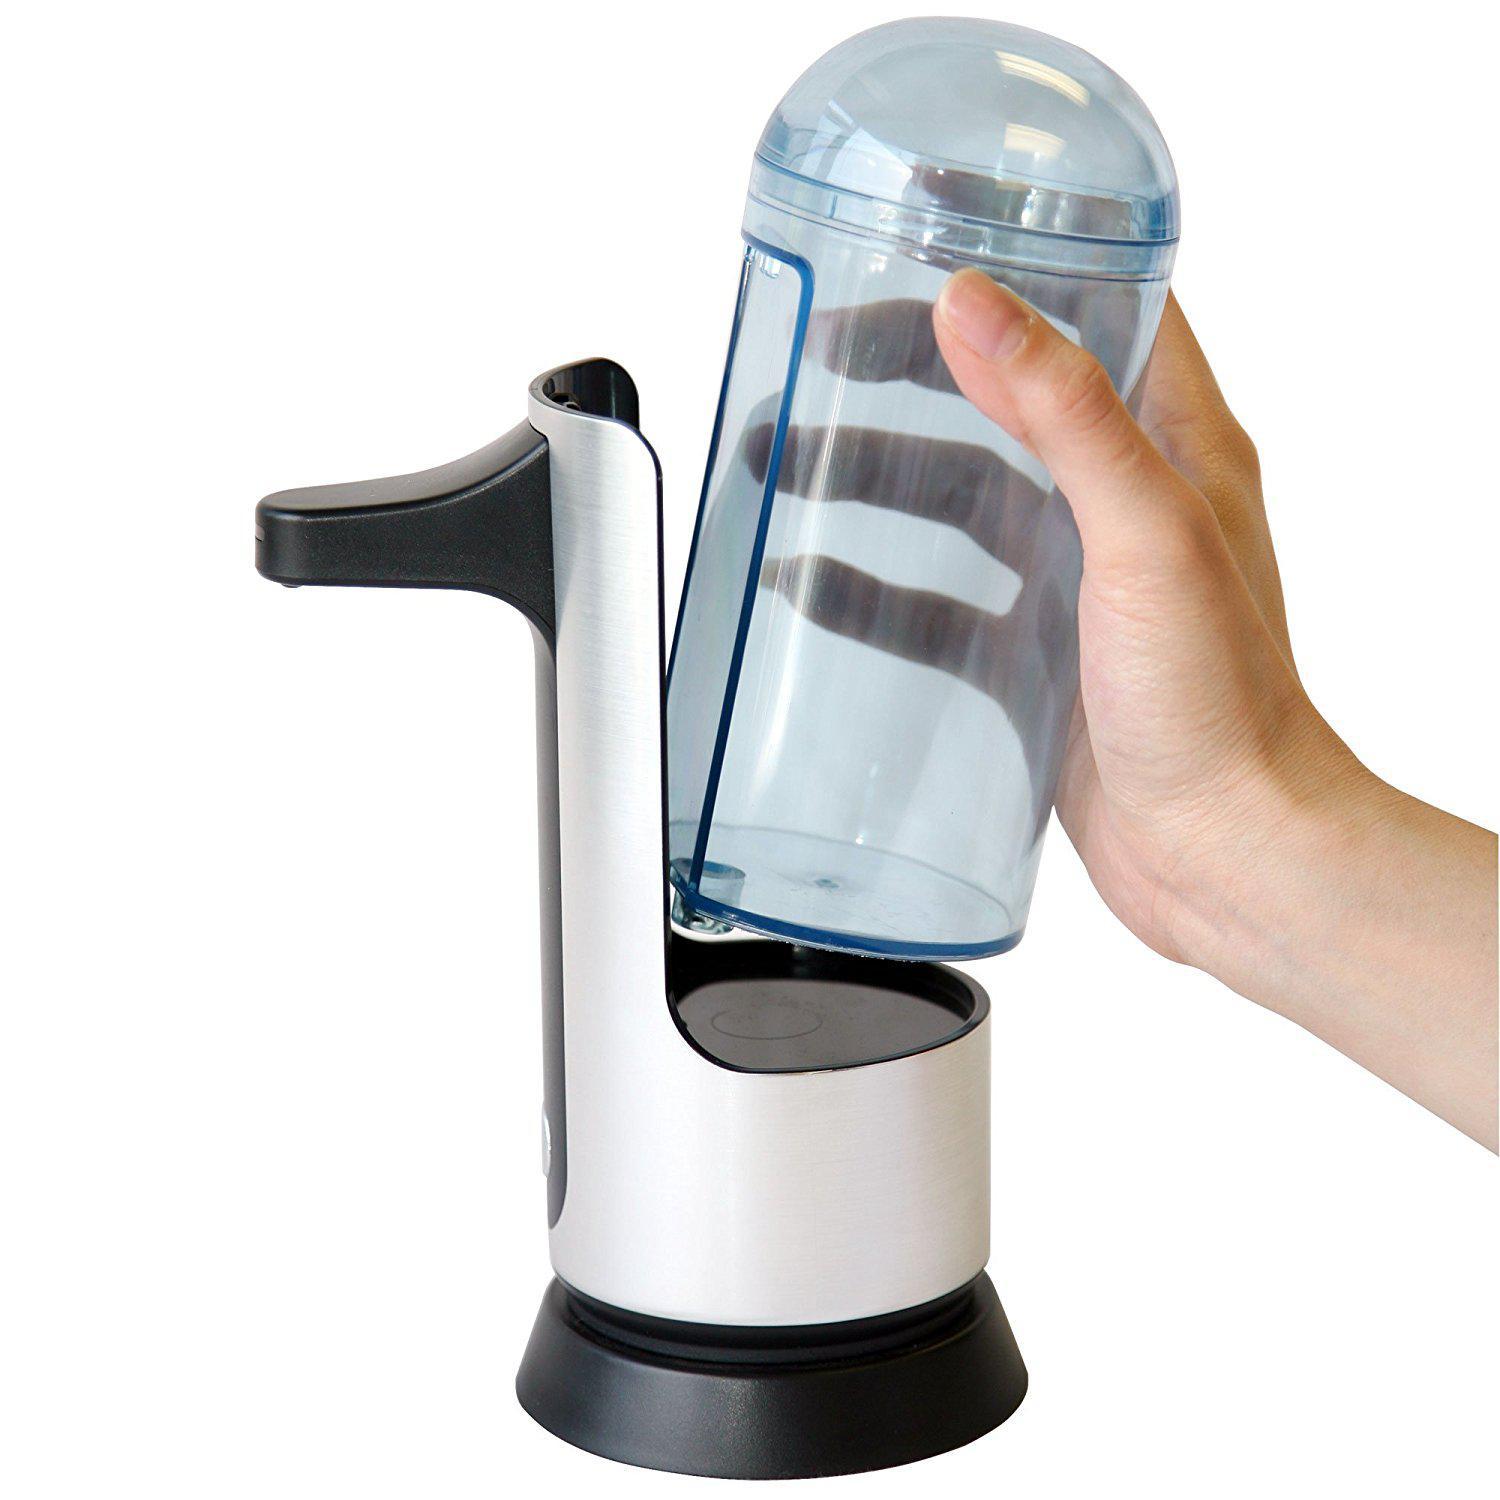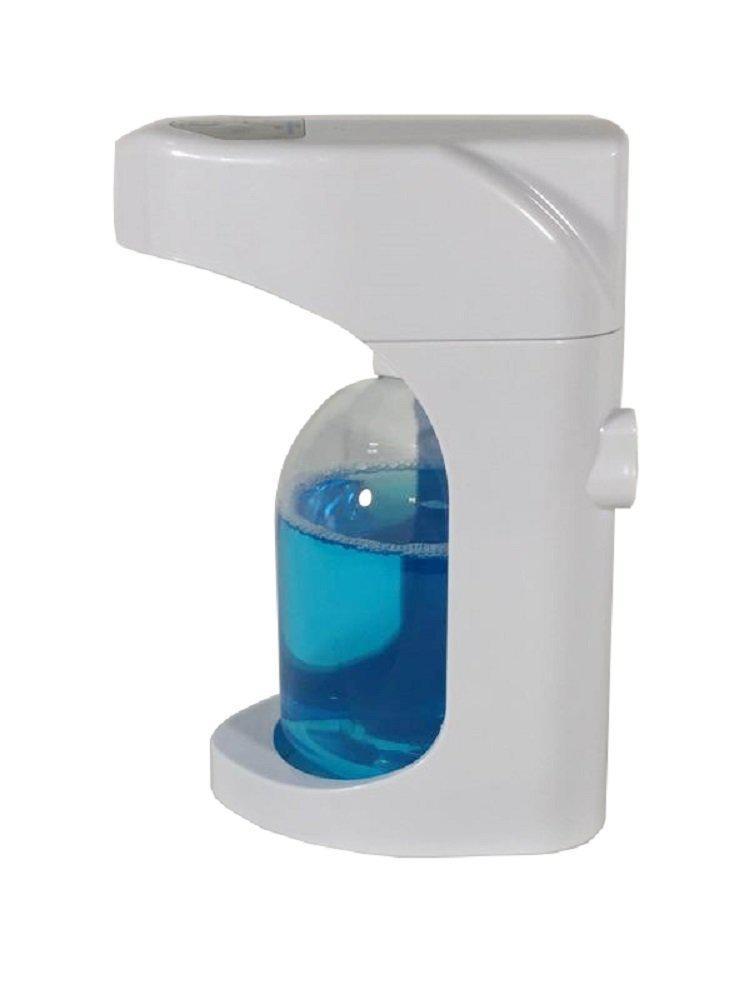The first image is the image on the left, the second image is the image on the right. For the images displayed, is the sentence "There is a human hand in the image on the left." factually correct? Answer yes or no. Yes. 